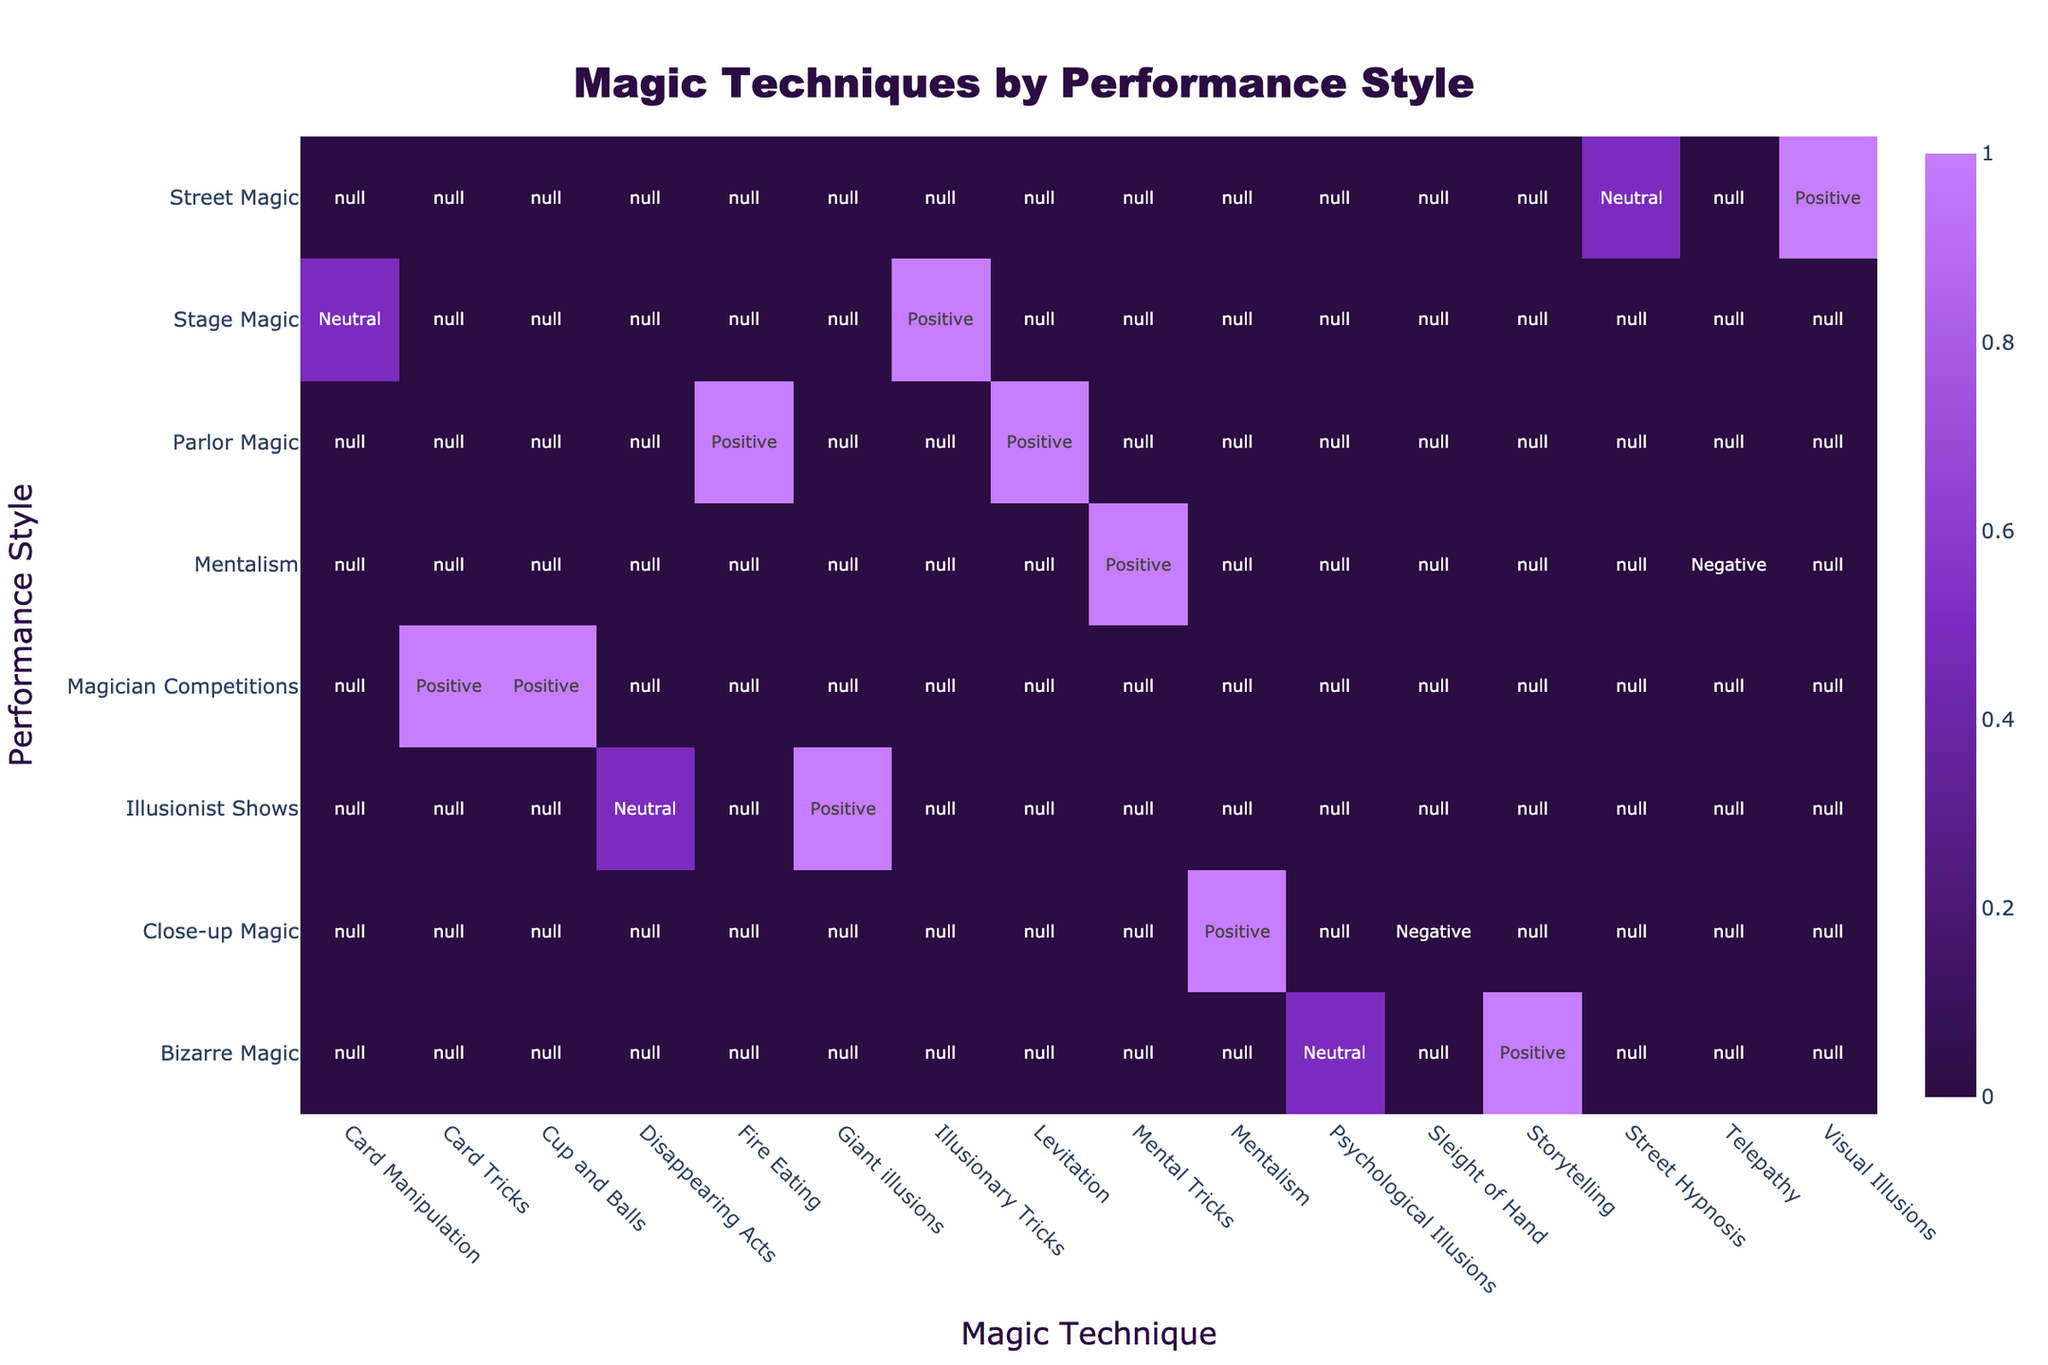What magic technique is most frequently associated with positive audience feedback in stage magic? In the crosstab, for the "Stage Magic" performance style, we see that "Illusionary Tricks" is the only magic technique associated with positive audience feedback.
Answer: Illusionary Tricks Which performance style has the highest number of positive feedbacks? To determine this, we count the number of positive feedbacks under each performance style: Stage Magic (1), Close-up Magic (1), Parlor Magic (2), Bizarre Magic (2), Street Magic (1), Mentalism (1), Illusionist Shows (1), and Magician Competitions (2). Parlor Magic, Bizarre Magic, and Magician Competitions all have 2, making them tied for the highest.
Answer: Parlor Magic, Bizarre Magic, Magician Competitions Is "Sleight of Hand" associated with neutral feedback? Looking at the "Close-up Magic" section, "Sleight of Hand" has negative feedback, not neutral, confirming that it is not associated with neutral feedback.
Answer: No Which performance styles have more than one technique? We analyze the table to see which performance styles list more than one magic technique. "Magician Competitions" has 2 techniques (Card Tricks and Cup and Balls), and "Parlor Magic" has 2 techniques (Fire Eating and Levitation). Therefore, these two performance styles have more than one technique.
Answer: Magician Competitions, Parlor Magic What is the total number of techniques used in close-up magic? In the crosstab for "Close-up Magic," we identify the techniques used, which are "Mentalism" and "Sleight of Hand," totaling to 2 techniques.
Answer: 2 Which performance style uses "Visual Illusions"? Referring to the table, "Visual Illusions" is listed under the "Street Magic" performance style, indicating that it is the only associated style.
Answer: Street Magic Are there any techniques that received only negative feedback? By scanning through the crosstab, "Sleight of Hand" and "Telepathy" received negative feedback, affirming that there are techniques specifically linked to negative audience reactions.
Answer: Yes What is the difference in the number of positive feedbacks between "Stage Magic" and "Magician Competitions"? For "Stage Magic," there is 1 positive feedback (Illusionary Tricks); for "Magician Competitions," there are 2 positives (Card Tricks and Cup and Balls). Therefore, the difference is 2 - 1 = 1, indicating that Magician Competitions has 1 more positive feedback.
Answer: 1 